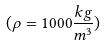<formula> <loc_0><loc_0><loc_500><loc_500>( \rho = 1 0 0 0 \frac { k g } { m ^ { 3 } } )</formula> 